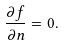<formula> <loc_0><loc_0><loc_500><loc_500>\frac { \partial f } { \partial n } = 0 .</formula> 